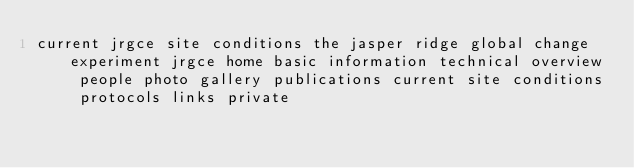<code> <loc_0><loc_0><loc_500><loc_500><_HTML_>current jrgce site conditions the jasper ridge global change experiment jrgce home basic information technical overview people photo gallery publications current site conditions protocols links private
</code> 